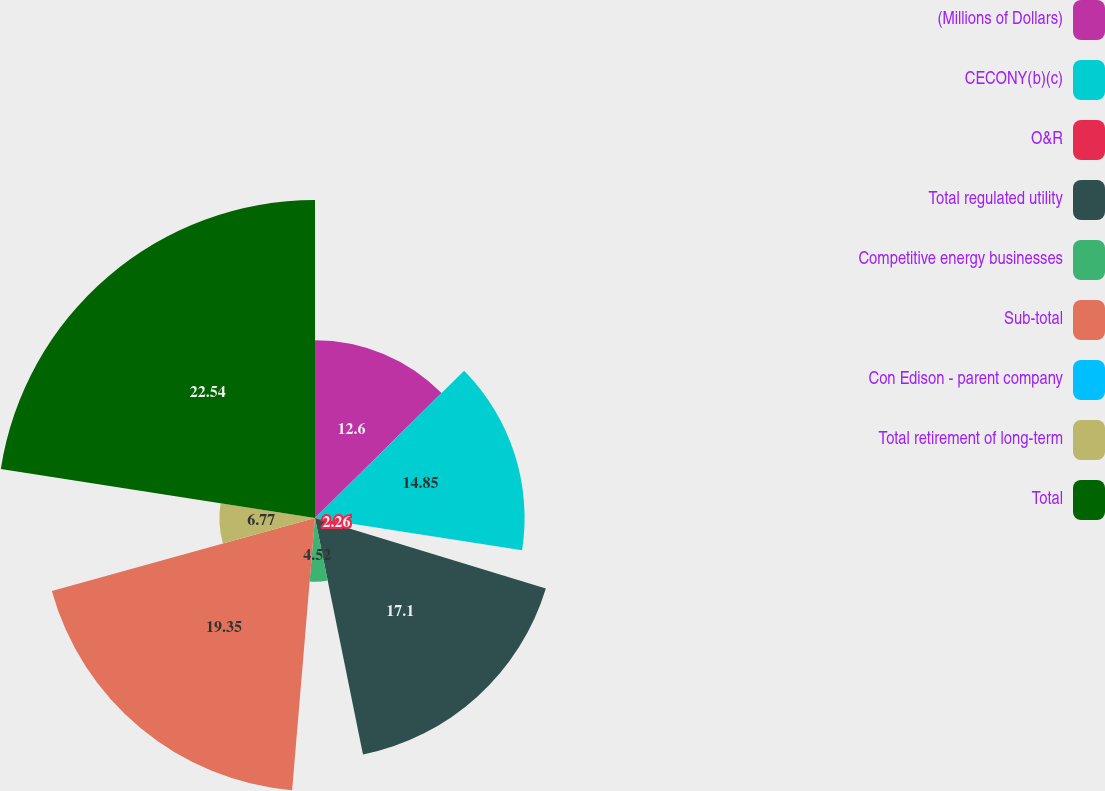Convert chart. <chart><loc_0><loc_0><loc_500><loc_500><pie_chart><fcel>(Millions of Dollars)<fcel>CECONY(b)(c)<fcel>O&R<fcel>Total regulated utility<fcel>Competitive energy businesses<fcel>Sub-total<fcel>Con Edison - parent company<fcel>Total retirement of long-term<fcel>Total<nl><fcel>12.6%<fcel>14.85%<fcel>2.26%<fcel>17.1%<fcel>4.52%<fcel>19.35%<fcel>0.01%<fcel>6.77%<fcel>22.53%<nl></chart> 